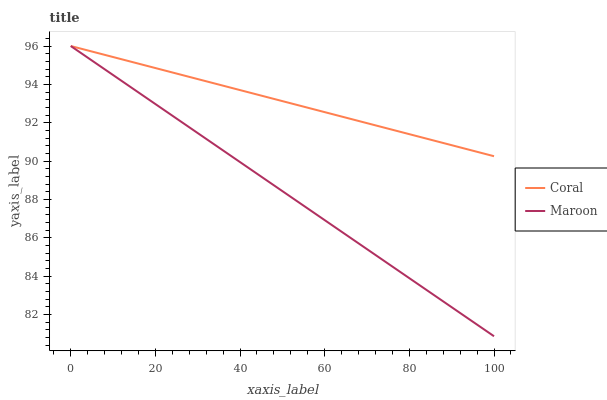Does Maroon have the maximum area under the curve?
Answer yes or no. No. Is Maroon the smoothest?
Answer yes or no. No. 